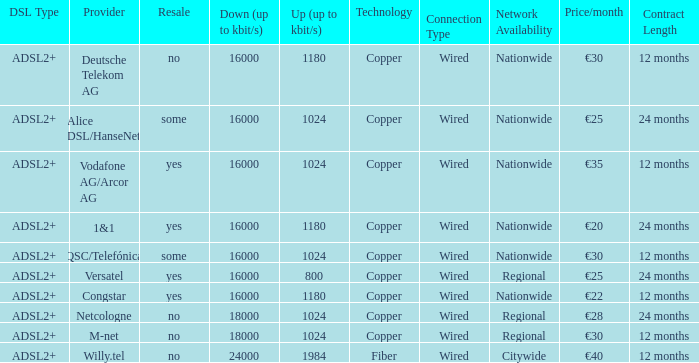What is the resale category for the provider NetCologne? No. 